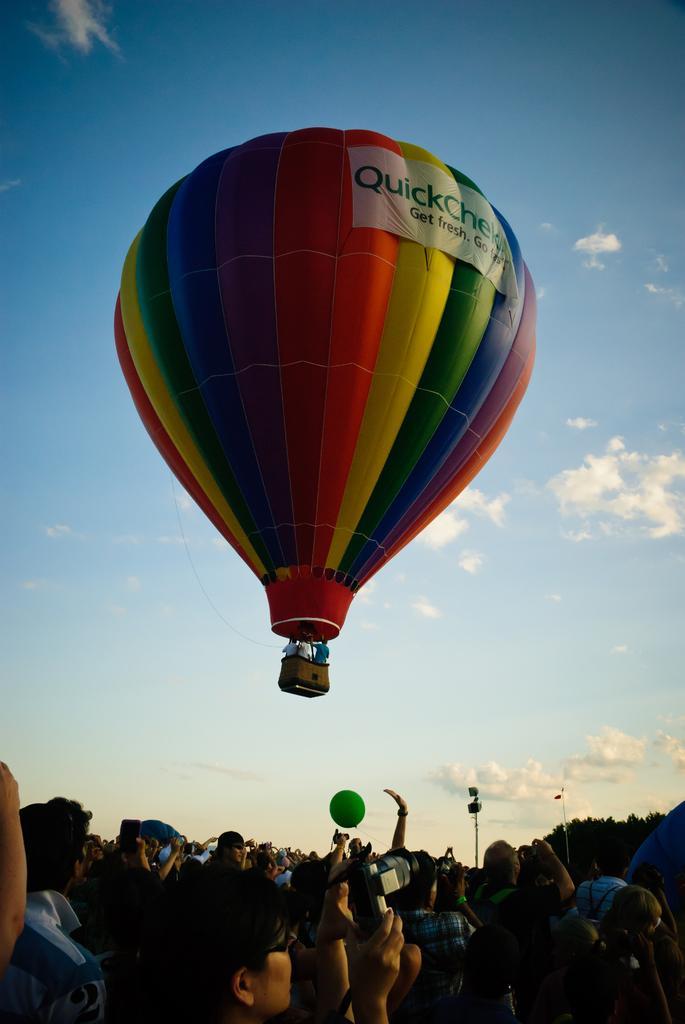Please provide a concise description of this image. In the image there is a hot air balloon in the air and below there are many people standing and taking pictures and above its sky with clouds. 